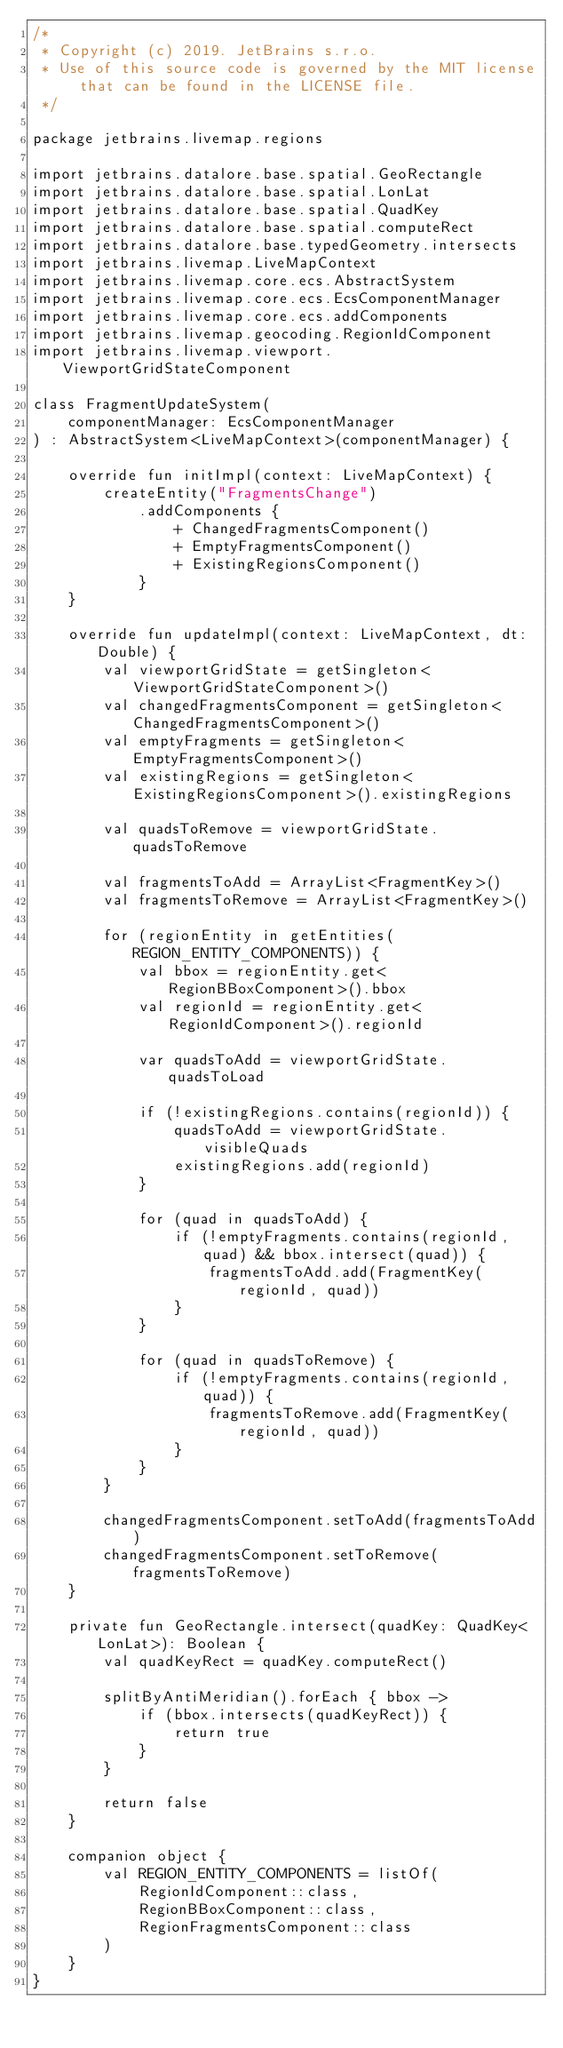<code> <loc_0><loc_0><loc_500><loc_500><_Kotlin_>/*
 * Copyright (c) 2019. JetBrains s.r.o.
 * Use of this source code is governed by the MIT license that can be found in the LICENSE file.
 */

package jetbrains.livemap.regions

import jetbrains.datalore.base.spatial.GeoRectangle
import jetbrains.datalore.base.spatial.LonLat
import jetbrains.datalore.base.spatial.QuadKey
import jetbrains.datalore.base.spatial.computeRect
import jetbrains.datalore.base.typedGeometry.intersects
import jetbrains.livemap.LiveMapContext
import jetbrains.livemap.core.ecs.AbstractSystem
import jetbrains.livemap.core.ecs.EcsComponentManager
import jetbrains.livemap.core.ecs.addComponents
import jetbrains.livemap.geocoding.RegionIdComponent
import jetbrains.livemap.viewport.ViewportGridStateComponent

class FragmentUpdateSystem(
    componentManager: EcsComponentManager
) : AbstractSystem<LiveMapContext>(componentManager) {

    override fun initImpl(context: LiveMapContext) {
        createEntity("FragmentsChange")
            .addComponents {
                + ChangedFragmentsComponent()
                + EmptyFragmentsComponent()
                + ExistingRegionsComponent()
            }
    }

    override fun updateImpl(context: LiveMapContext, dt: Double) {
        val viewportGridState = getSingleton<ViewportGridStateComponent>()
        val changedFragmentsComponent = getSingleton<ChangedFragmentsComponent>()
        val emptyFragments = getSingleton<EmptyFragmentsComponent>()
        val existingRegions = getSingleton<ExistingRegionsComponent>().existingRegions

        val quadsToRemove = viewportGridState.quadsToRemove

        val fragmentsToAdd = ArrayList<FragmentKey>()
        val fragmentsToRemove = ArrayList<FragmentKey>()

        for (regionEntity in getEntities(REGION_ENTITY_COMPONENTS)) {
            val bbox = regionEntity.get<RegionBBoxComponent>().bbox
            val regionId = regionEntity.get<RegionIdComponent>().regionId

            var quadsToAdd = viewportGridState.quadsToLoad

            if (!existingRegions.contains(regionId)) {
                quadsToAdd = viewportGridState.visibleQuads
                existingRegions.add(regionId)
            }

            for (quad in quadsToAdd) {
                if (!emptyFragments.contains(regionId, quad) && bbox.intersect(quad)) {
                    fragmentsToAdd.add(FragmentKey(regionId, quad))
                }
            }

            for (quad in quadsToRemove) {
                if (!emptyFragments.contains(regionId, quad)) {
                    fragmentsToRemove.add(FragmentKey(regionId, quad))
                }
            }
        }

        changedFragmentsComponent.setToAdd(fragmentsToAdd)
        changedFragmentsComponent.setToRemove(fragmentsToRemove)
    }

    private fun GeoRectangle.intersect(quadKey: QuadKey<LonLat>): Boolean {
        val quadKeyRect = quadKey.computeRect()

        splitByAntiMeridian().forEach { bbox ->
            if (bbox.intersects(quadKeyRect)) {
                return true
            }
        }

        return false
    }

    companion object {
        val REGION_ENTITY_COMPONENTS = listOf(
            RegionIdComponent::class,
            RegionBBoxComponent::class,
            RegionFragmentsComponent::class
        )
    }
}</code> 